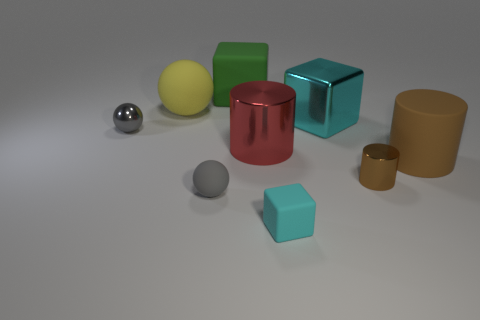Are there any large metallic blocks of the same color as the tiny cube?
Offer a terse response. Yes. The other cylinder that is the same color as the rubber cylinder is what size?
Make the answer very short. Small. What is the shape of the metal object that is the same color as the small rubber ball?
Your response must be concise. Sphere. What shape is the big metallic thing on the right side of the small cyan cube?
Your answer should be compact. Cube. Is the color of the tiny matte sphere the same as the small sphere that is behind the small brown metallic thing?
Give a very brief answer. Yes. Are there the same number of large cyan blocks that are right of the brown metallic cylinder and small spheres that are left of the big green thing?
Provide a short and direct response. No. What number of other things are there of the same size as the yellow matte object?
Make the answer very short. 4. How big is the gray rubber object?
Provide a succinct answer. Small. Does the large green thing have the same material as the cylinder that is to the left of the big cyan shiny cube?
Keep it short and to the point. No. Are there any gray metal objects that have the same shape as the yellow thing?
Offer a very short reply. Yes. 